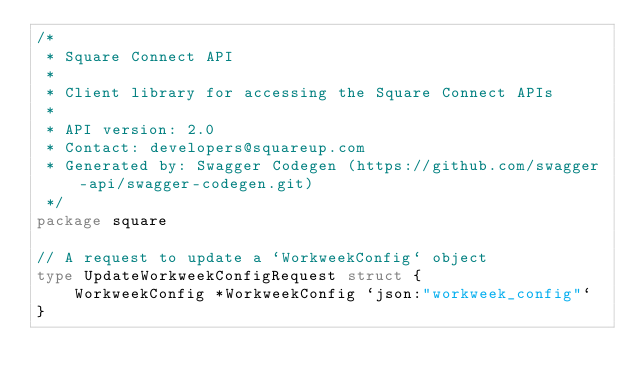<code> <loc_0><loc_0><loc_500><loc_500><_Go_>/*
 * Square Connect API
 *
 * Client library for accessing the Square Connect APIs
 *
 * API version: 2.0
 * Contact: developers@squareup.com
 * Generated by: Swagger Codegen (https://github.com/swagger-api/swagger-codegen.git)
 */
package square

// A request to update a `WorkweekConfig` object
type UpdateWorkweekConfigRequest struct {
	WorkweekConfig *WorkweekConfig `json:"workweek_config"`
}
</code> 